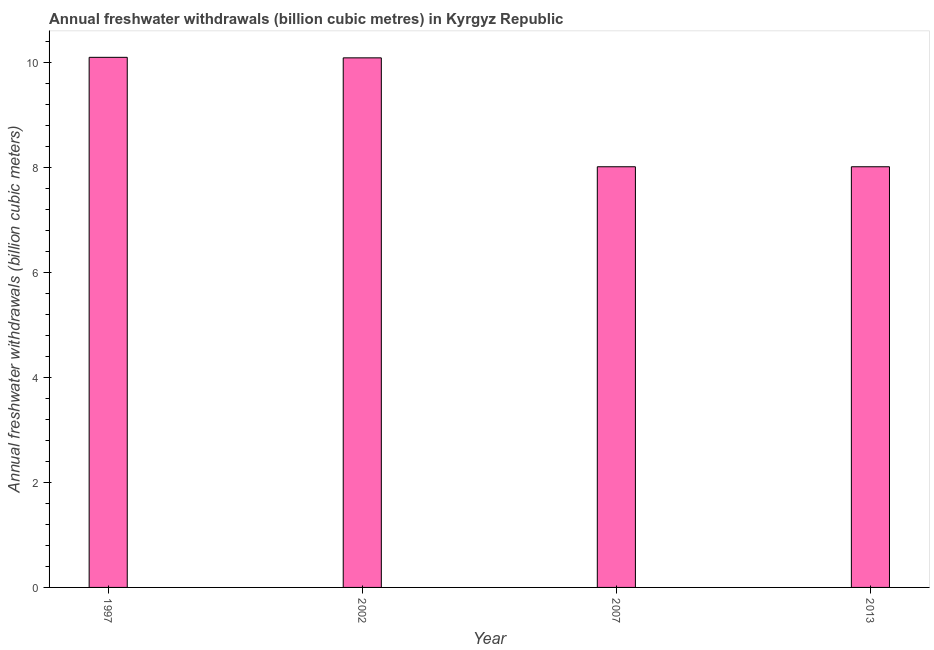Does the graph contain grids?
Keep it short and to the point. No. What is the title of the graph?
Your answer should be compact. Annual freshwater withdrawals (billion cubic metres) in Kyrgyz Republic. What is the label or title of the Y-axis?
Offer a very short reply. Annual freshwater withdrawals (billion cubic meters). What is the annual freshwater withdrawals in 2013?
Keep it short and to the point. 8.01. Across all years, what is the maximum annual freshwater withdrawals?
Offer a terse response. 10.09. Across all years, what is the minimum annual freshwater withdrawals?
Give a very brief answer. 8.01. In which year was the annual freshwater withdrawals maximum?
Make the answer very short. 1997. What is the sum of the annual freshwater withdrawals?
Make the answer very short. 36.18. What is the difference between the annual freshwater withdrawals in 1997 and 2007?
Your answer should be compact. 2.08. What is the average annual freshwater withdrawals per year?
Ensure brevity in your answer.  9.05. What is the median annual freshwater withdrawals?
Your answer should be very brief. 9.04. Do a majority of the years between 2002 and 2013 (inclusive) have annual freshwater withdrawals greater than 7.2 billion cubic meters?
Provide a short and direct response. Yes. What is the difference between the highest and the lowest annual freshwater withdrawals?
Your answer should be very brief. 2.08. In how many years, is the annual freshwater withdrawals greater than the average annual freshwater withdrawals taken over all years?
Provide a short and direct response. 2. How many bars are there?
Your answer should be very brief. 4. How many years are there in the graph?
Your response must be concise. 4. What is the difference between two consecutive major ticks on the Y-axis?
Make the answer very short. 2. Are the values on the major ticks of Y-axis written in scientific E-notation?
Make the answer very short. No. What is the Annual freshwater withdrawals (billion cubic meters) of 1997?
Give a very brief answer. 10.09. What is the Annual freshwater withdrawals (billion cubic meters) of 2002?
Provide a succinct answer. 10.08. What is the Annual freshwater withdrawals (billion cubic meters) in 2007?
Offer a very short reply. 8.01. What is the Annual freshwater withdrawals (billion cubic meters) in 2013?
Provide a short and direct response. 8.01. What is the difference between the Annual freshwater withdrawals (billion cubic meters) in 1997 and 2002?
Give a very brief answer. 0.01. What is the difference between the Annual freshwater withdrawals (billion cubic meters) in 1997 and 2007?
Offer a terse response. 2.08. What is the difference between the Annual freshwater withdrawals (billion cubic meters) in 1997 and 2013?
Your answer should be very brief. 2.08. What is the difference between the Annual freshwater withdrawals (billion cubic meters) in 2002 and 2007?
Make the answer very short. 2.07. What is the difference between the Annual freshwater withdrawals (billion cubic meters) in 2002 and 2013?
Make the answer very short. 2.07. What is the ratio of the Annual freshwater withdrawals (billion cubic meters) in 1997 to that in 2007?
Your response must be concise. 1.26. What is the ratio of the Annual freshwater withdrawals (billion cubic meters) in 1997 to that in 2013?
Your response must be concise. 1.26. What is the ratio of the Annual freshwater withdrawals (billion cubic meters) in 2002 to that in 2007?
Offer a terse response. 1.26. What is the ratio of the Annual freshwater withdrawals (billion cubic meters) in 2002 to that in 2013?
Your response must be concise. 1.26. What is the ratio of the Annual freshwater withdrawals (billion cubic meters) in 2007 to that in 2013?
Ensure brevity in your answer.  1. 